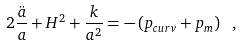<formula> <loc_0><loc_0><loc_500><loc_500>2 \frac { \ddot { a } } { a } + H ^ { 2 } + \frac { k } { a ^ { 2 } } = - \left ( p _ { c u r v } + p _ { m } \right ) \ ,</formula> 